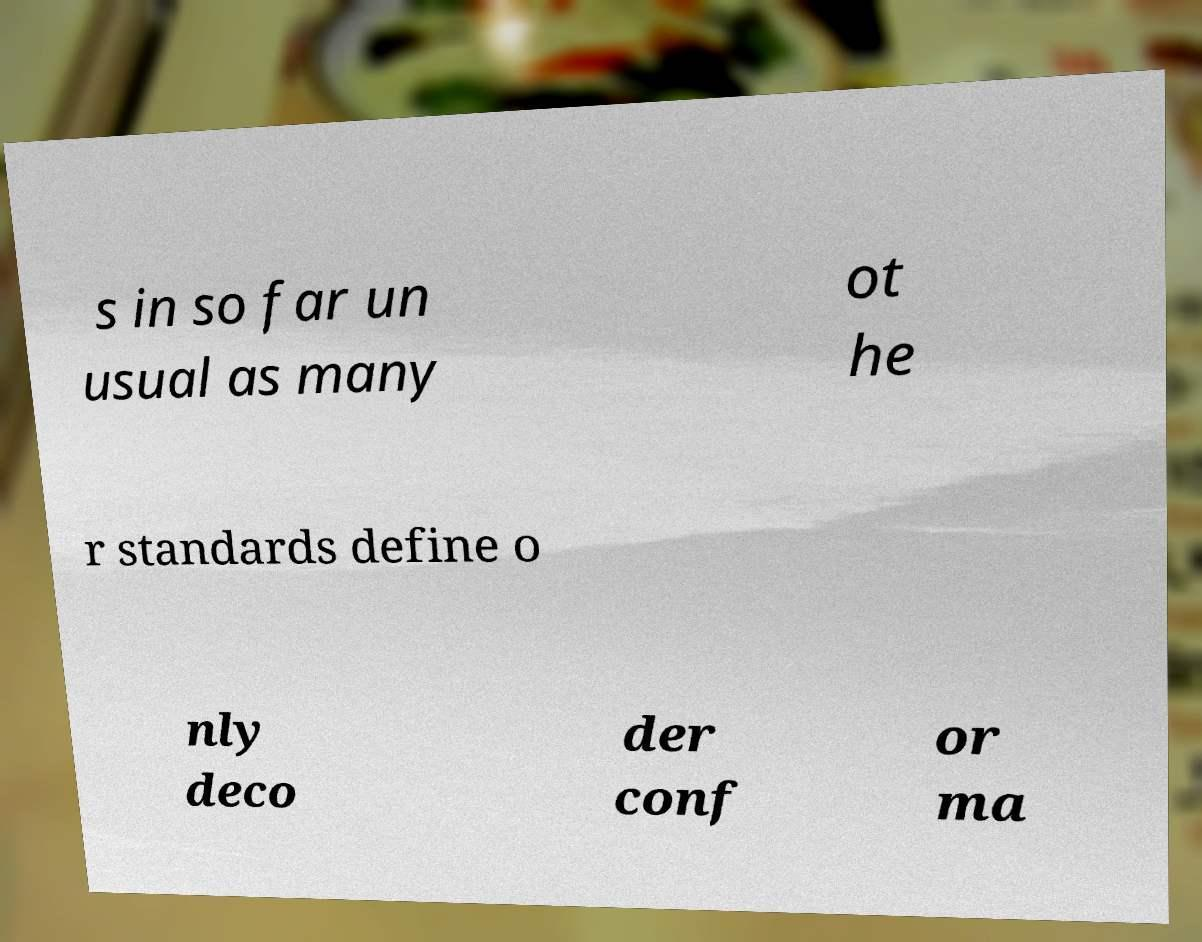Could you extract and type out the text from this image? s in so far un usual as many ot he r standards define o nly deco der conf or ma 